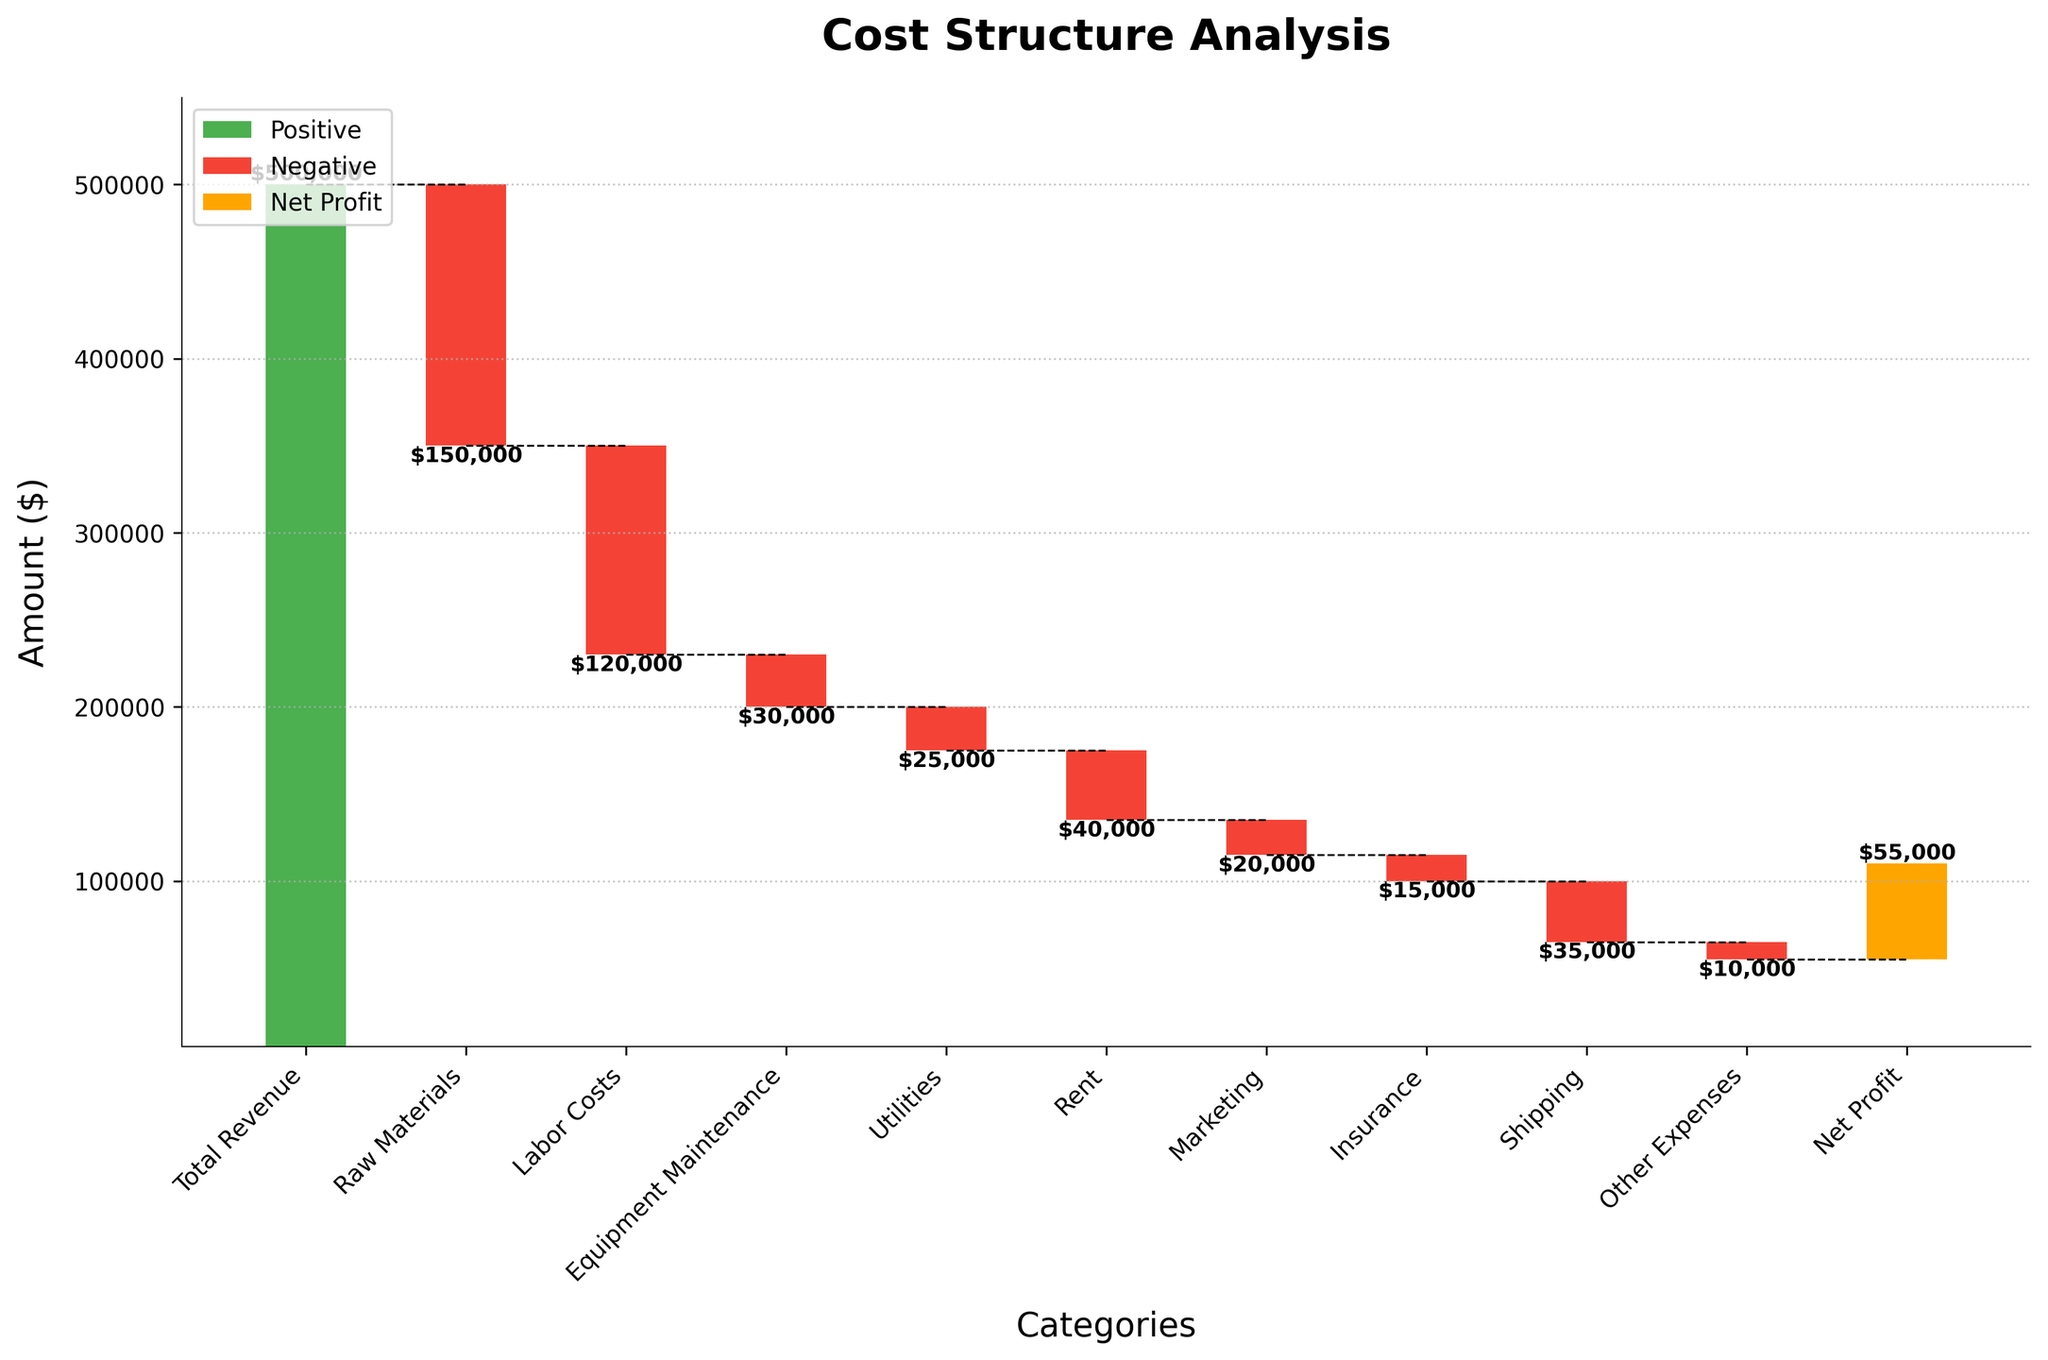What is the title of the chart? The title is displayed at the top of the chart, indicating what the chart is about.
Answer: Cost Structure Analysis How many categories are displayed in the chart? Count the number of labels on the x-axis.
Answer: 11 Which category has the highest negative amount? Examine the bars with negative values (red bars) and find the one with the largest negative number.
Answer: Raw Materials What is the net profit amount? Look at the final bar labeled "Net Profit" to see the value.
Answer: $55,000 By how much do labor costs decrease the cumulative amount? Identify the bar labeled "Labor Costs," which is one of the red bars, and note its value.
Answer: $120,000 What is the total revenue indicated on the chart? The first bar on the chart represents the total revenue, indicated in green.
Answer: $500,000 How do marketing expenses compare to rent expenses? Examine the heights or values of the bars labeled "Marketing" and "Rent" and compare them.
Answer: Marketing costs are $20,000, while Rent is $40,000 What is the difference between the amounts for utilities and insurance? Subtract the amount of the "Insurance" category from the "Utilities" category.
Answer: $10,000 Which category contributes the least to the expenses, excluding the net profit and total revenue? Identify the smallest negative value among the expense categories (red bars).
Answer: Other Expenses What are the cumulative effects of Raw Materials and Labor Costs on total revenue? Add the amounts for "Raw Materials" and "Labor Costs" and subtract from "Total Revenue."
Answer: ($150,000 + $120,000) = $270,000 decrease 